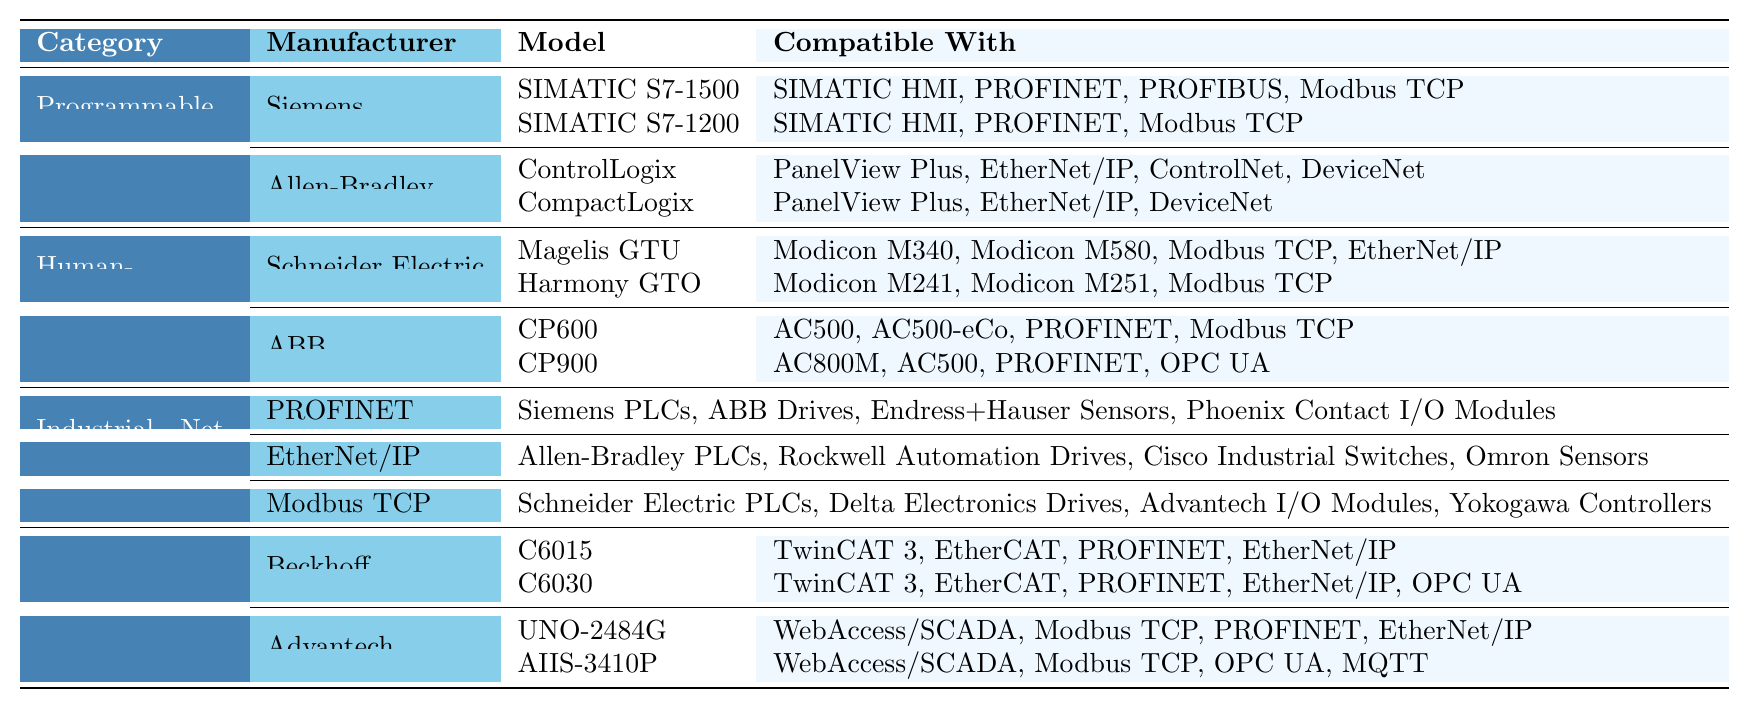What are the compatible protocols for the ControlLogix model from Allen-Bradley? The ControlLogix model is compatible with PanelView Plus, EtherNet/IP, ControlNet, and DeviceNet. This information is found in the table under the section for Allen-Bradley models.
Answer: PanelView Plus, EtherNet/IP, ControlNet, DeviceNet Which PLC model from Siemens is compatible with PROFIBUS? The SIMATIC S7-1500 model from Siemens is compatible with PROFIBUS, as indicated in the compatibility list for this specific model.
Answer: SIMATIC S7-1500 How many models of HMIs are listed for Schneider Electric? Schneider Electric has two models of HMIs listed: Magelis GTU and Harmony GTO. This is determined by counting the model entries under the Schneider Electric manufacturer in the HMI category.
Answer: 2 Is the CP900 model of ABB compatible with MODBUS TCP? Yes, the CP900 model from ABB is compatible with Modbus TCP, which is specified in the table under the compatibility section for this model.
Answer: Yes What is the total number of devices compatible with the PROFINET protocol listed in the table? The table indicates that four types of devices are compatible with the PROFINET protocol: Siemens PLCs, ABB Drives, Endress+Hauser Sensors, and Phoenix Contact I/O Modules. Thus, the total is 4.
Answer: 4 Which manufacturer has a model compatible with both OPC UA and EtherNet/IP? The AIIS-3410P model from Advantech is compatible with both OPC UA and EtherNet/IP, as shown in the compatibility list for this model.
Answer: Advantech If a user wants to connect to Modbus TCP, which manufacturers could they choose from? A user could choose Schneider Electric and Advantech, since both have models that are compatible with Modbus TCP. This is based on the compatibility details listed for the models from these manufacturers.
Answer: Schneider Electric, Advantech Which PLC models are compatible with both PanelView Plus and DeviceNet? The CompactLogix model from Allen-Bradley is compatible with both PanelView Plus and DeviceNet. This can be confirmed by checking the compatibility list under its section.
Answer: CompactLogix If a PLC model is compatible with EtherNet/IP, which brand must it belong to? The model must belong to Allen-Bradley, as only their models (ControlLogix and CompactLogix) show this compatibility with EtherNet/IP in the table.
Answer: Allen-Bradley How many models does Beckhoff offer that are compatible with PROFINET? Beckhoff offers two models (C6015 and C6030) that are compatible with PROFINET, as indicated in their section under Industrial PCs. This confirms both models’ compatibility with PROFINET.
Answer: 2 